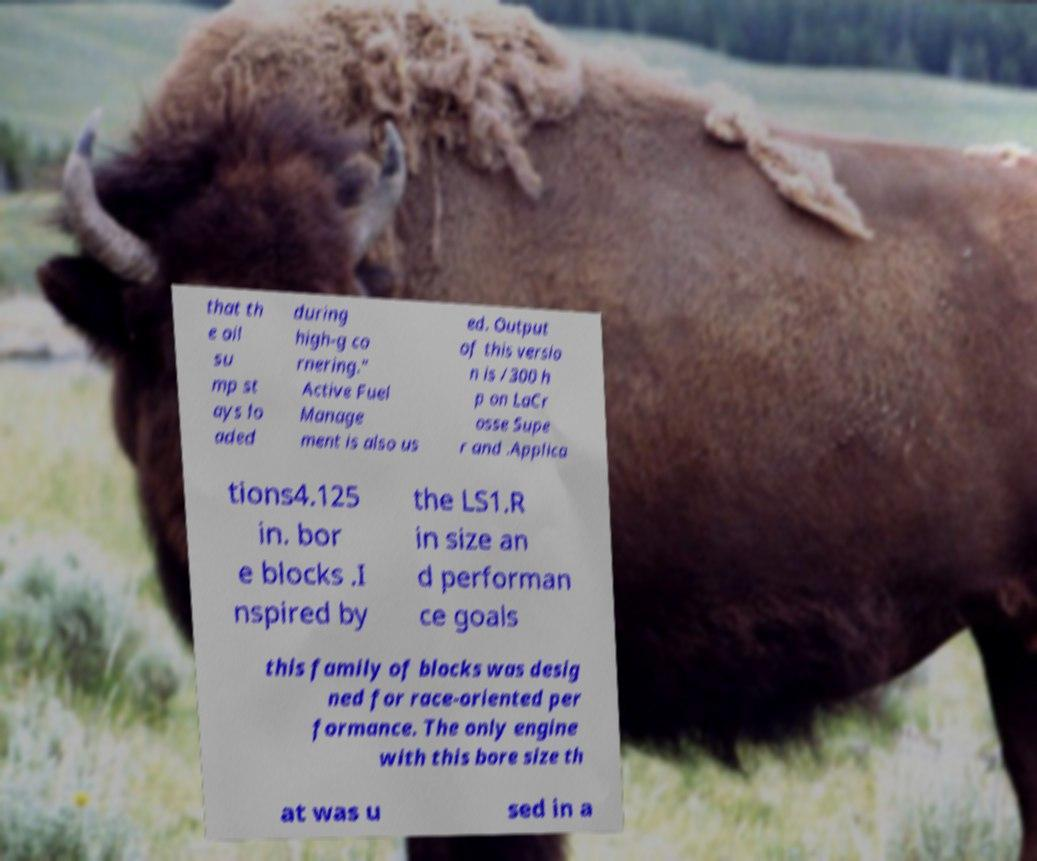There's text embedded in this image that I need extracted. Can you transcribe it verbatim? that th e oil su mp st ays lo aded during high-g co rnering." Active Fuel Manage ment is also us ed. Output of this versio n is /300 h p on LaCr osse Supe r and .Applica tions4.125 in. bor e blocks .I nspired by the LS1.R in size an d performan ce goals this family of blocks was desig ned for race-oriented per formance. The only engine with this bore size th at was u sed in a 